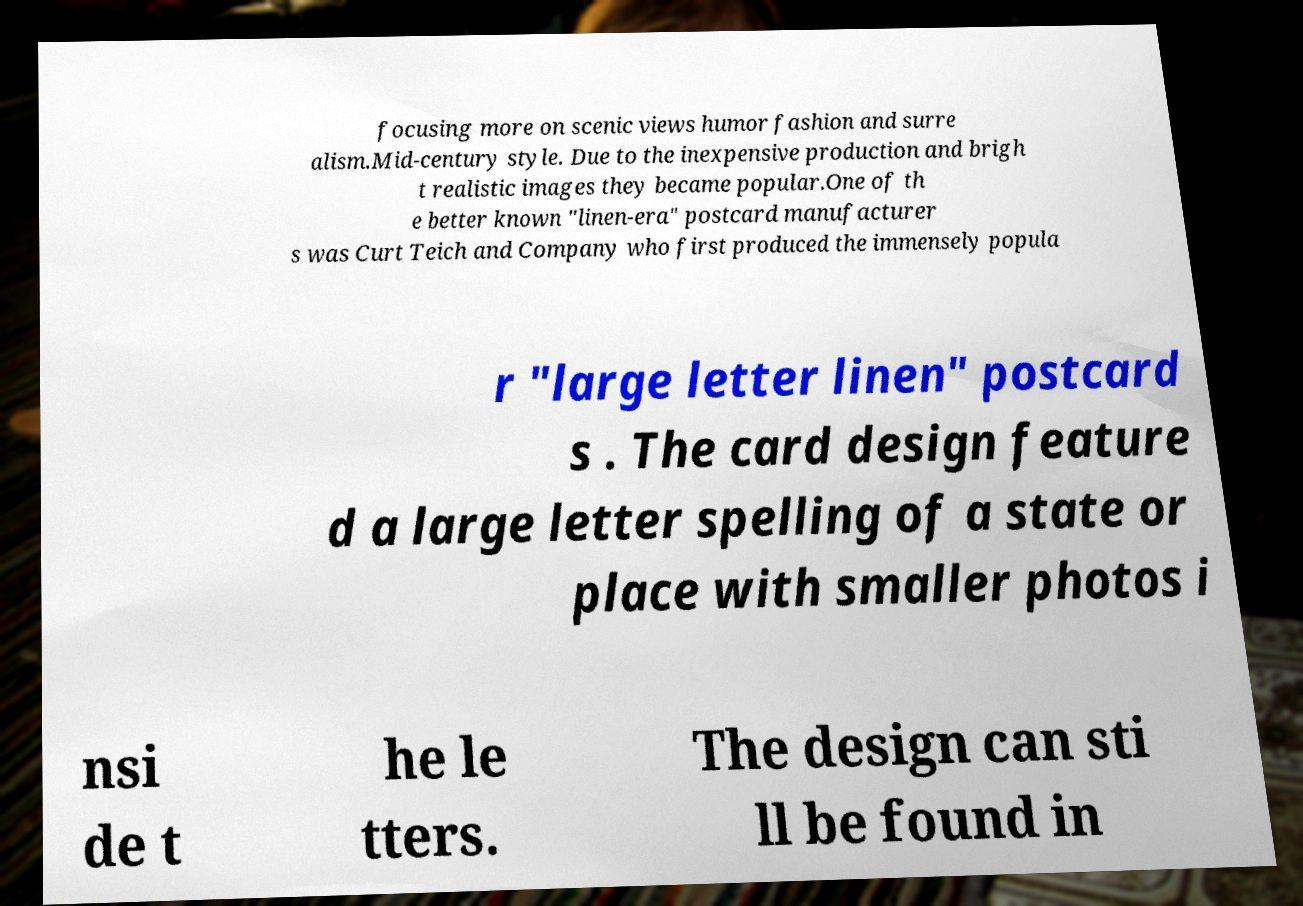What messages or text are displayed in this image? I need them in a readable, typed format. focusing more on scenic views humor fashion and surre alism.Mid-century style. Due to the inexpensive production and brigh t realistic images they became popular.One of th e better known "linen-era" postcard manufacturer s was Curt Teich and Company who first produced the immensely popula r "large letter linen" postcard s . The card design feature d a large letter spelling of a state or place with smaller photos i nsi de t he le tters. The design can sti ll be found in 